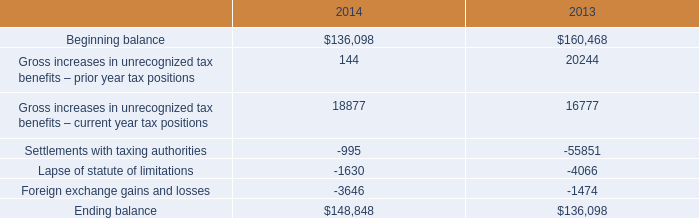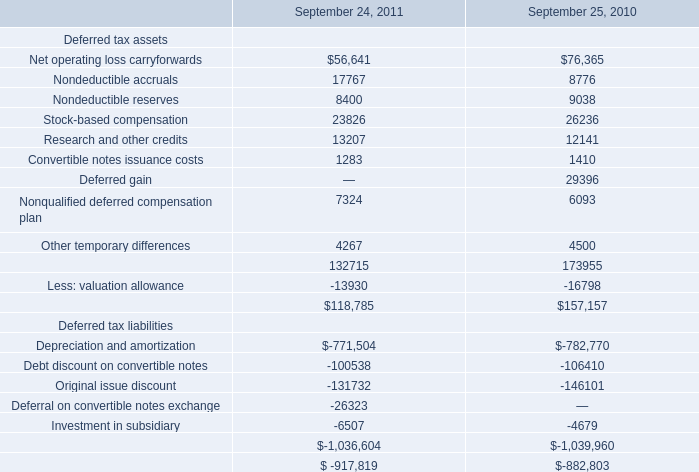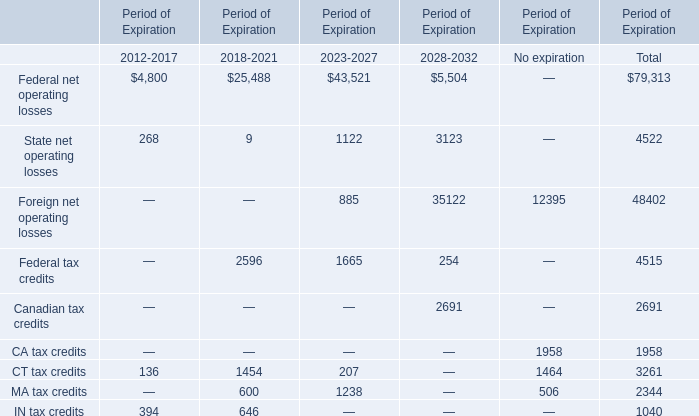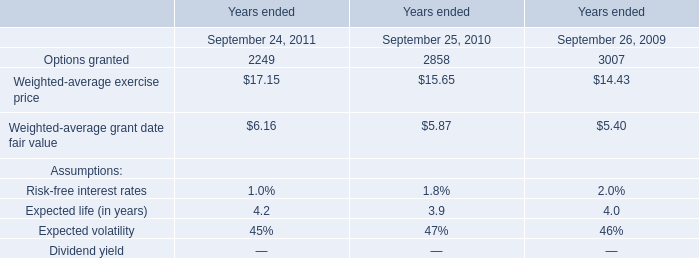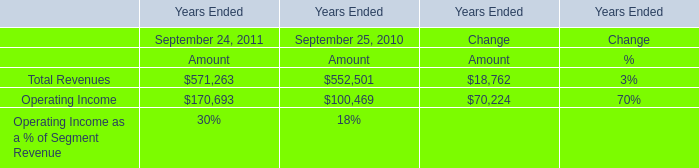In the section with largest amount of Canadian tax credits, what's the sum of elements? 
Computations: ((((5504 + 3123) + 35122) + 254) + 2691)
Answer: 46694.0. 